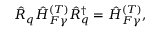<formula> <loc_0><loc_0><loc_500><loc_500>\begin{array} { r } { \hat { R } _ { q } \hat { H } _ { F \gamma } ^ { ( T ) } \hat { R } _ { q } ^ { \dagger } = \hat { H } _ { F \gamma } ^ { ( T ) } , } \end{array}</formula> 